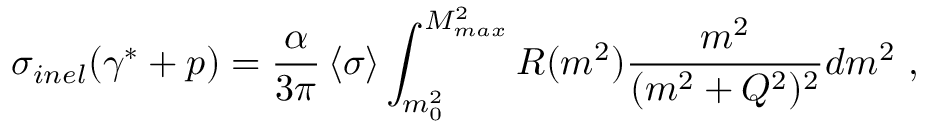<formula> <loc_0><loc_0><loc_500><loc_500>\sigma _ { i n e l } ( \gamma ^ { * } + p ) = { \frac { \alpha } { 3 \pi } } \left < \sigma \right > \int _ { m _ { 0 } ^ { 2 } } ^ { M _ { \max } ^ { 2 } } R ( m ^ { 2 } ) { \frac { m ^ { 2 } } { ( m ^ { 2 } + Q ^ { 2 } ) ^ { 2 } } } d m ^ { 2 } \ ,</formula> 